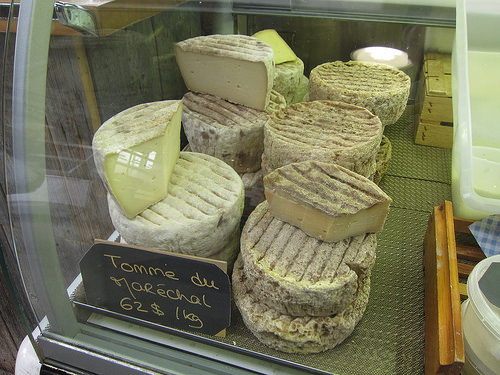<image>
Is the slice on the slice? No. The slice is not positioned on the slice. They may be near each other, but the slice is not supported by or resting on top of the slice. 